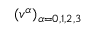<formula> <loc_0><loc_0><loc_500><loc_500>( v ^ { \alpha } ) _ { \alpha = 0 , 1 , 2 , 3 }</formula> 